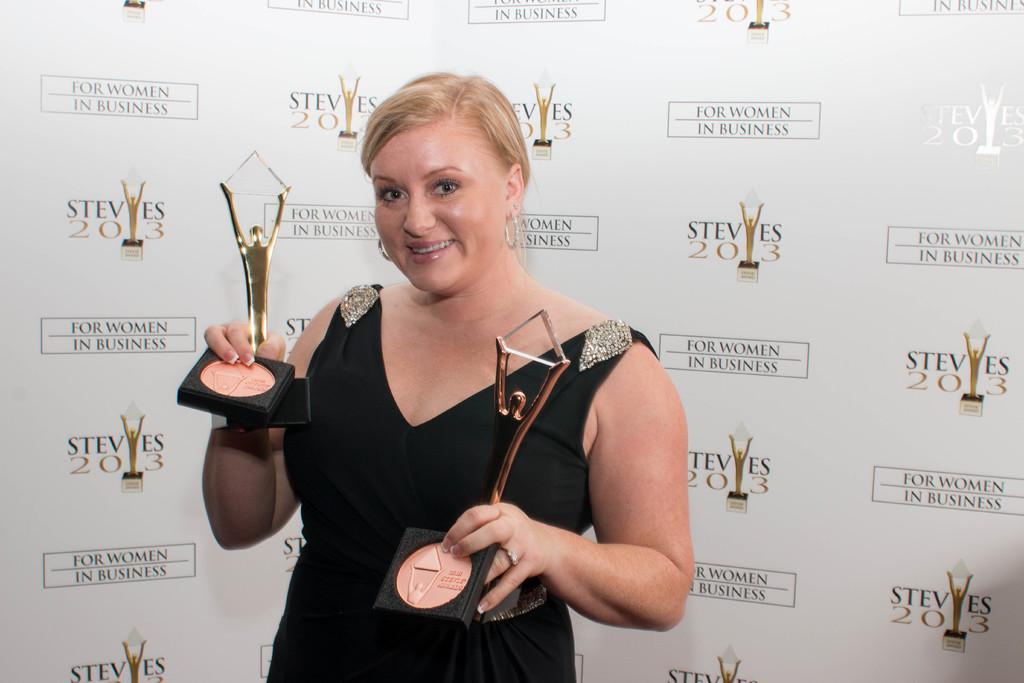Could you give a brief overview of what you see in this image? In this picture we can see a woman standing and holding awards in her hands. She is smiling. We can see a poster in the background. 